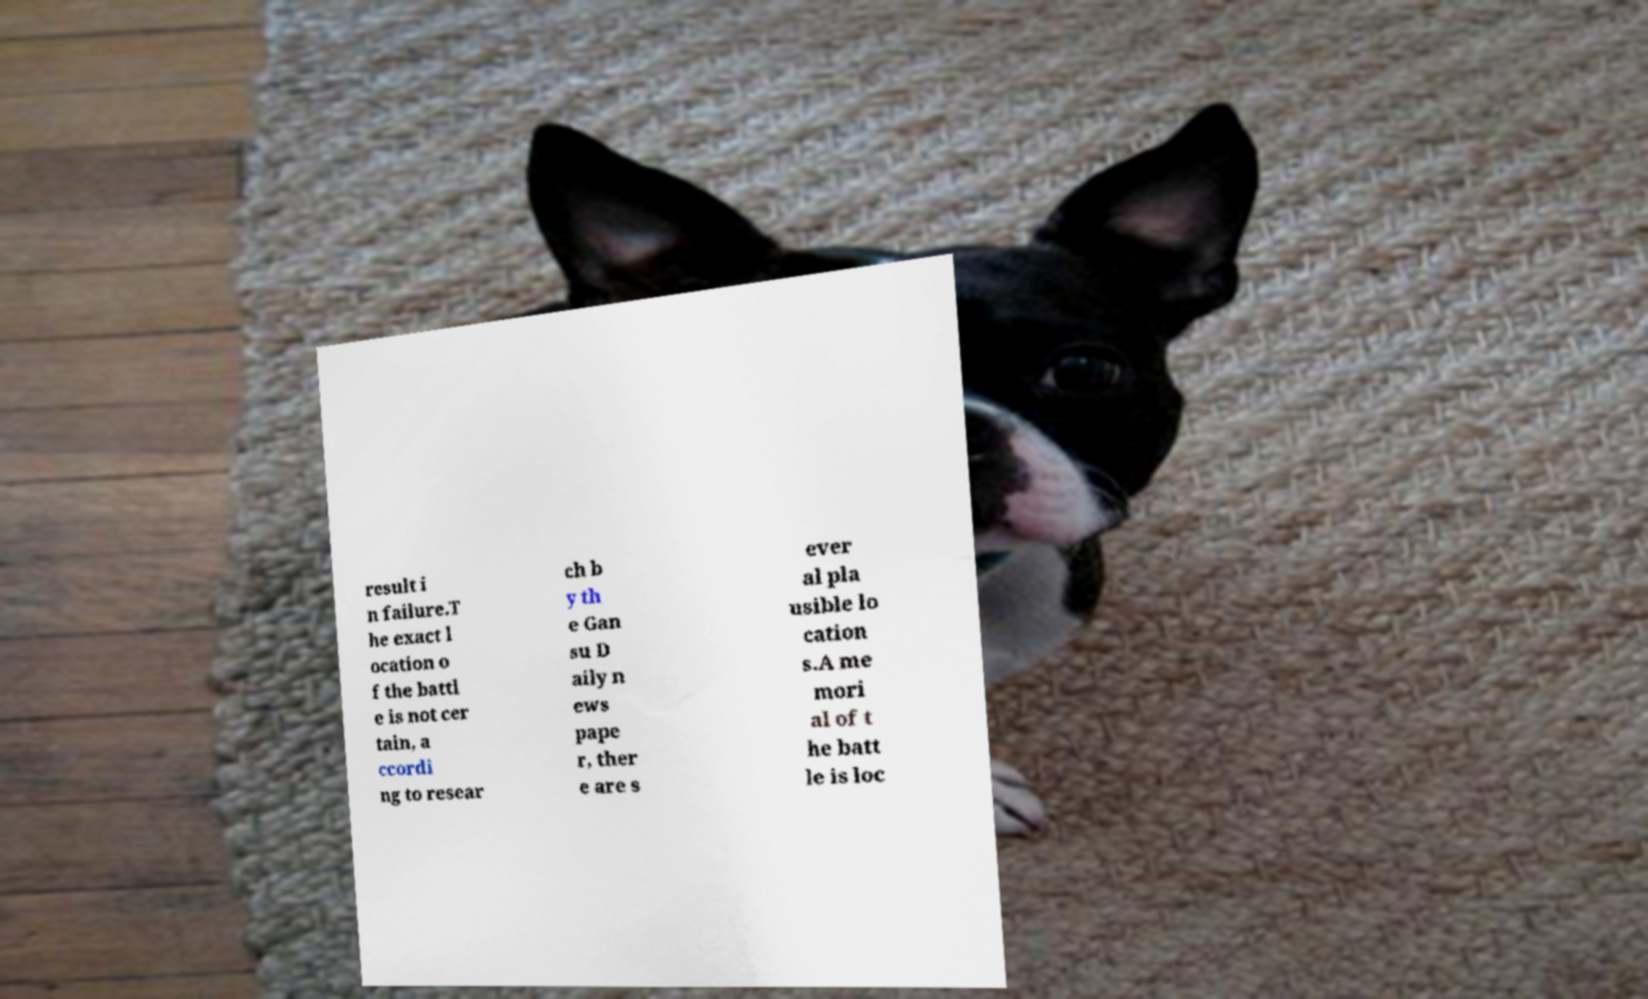Please identify and transcribe the text found in this image. result i n failure.T he exact l ocation o f the battl e is not cer tain, a ccordi ng to resear ch b y th e Gan su D aily n ews pape r, ther e are s ever al pla usible lo cation s.A me mori al of t he batt le is loc 